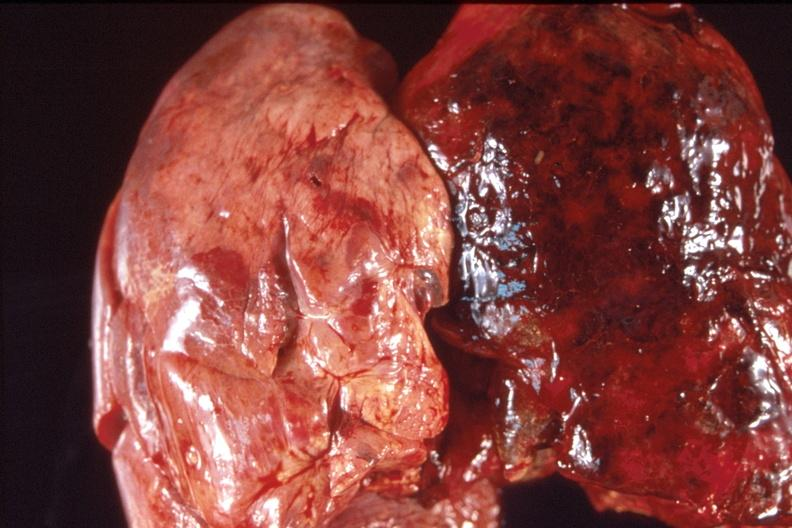does hand show lung, hemorrhagic fibrinous pleuritis?
Answer the question using a single word or phrase. No 